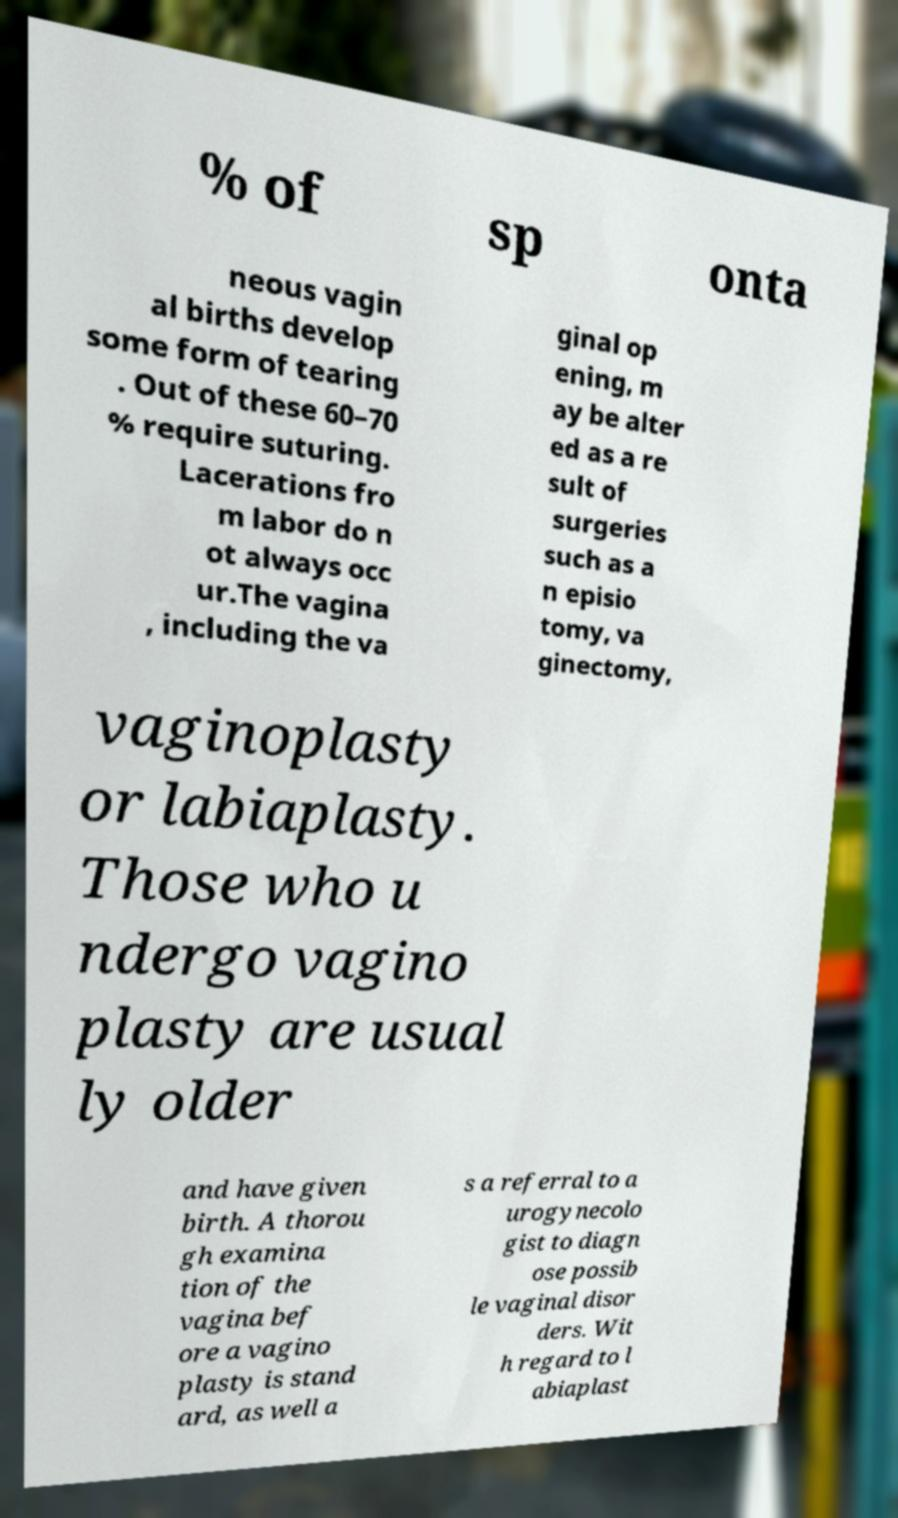Please read and relay the text visible in this image. What does it say? % of sp onta neous vagin al births develop some form of tearing . Out of these 60–70 % require suturing. Lacerations fro m labor do n ot always occ ur.The vagina , including the va ginal op ening, m ay be alter ed as a re sult of surgeries such as a n episio tomy, va ginectomy, vaginoplasty or labiaplasty. Those who u ndergo vagino plasty are usual ly older and have given birth. A thorou gh examina tion of the vagina bef ore a vagino plasty is stand ard, as well a s a referral to a urogynecolo gist to diagn ose possib le vaginal disor ders. Wit h regard to l abiaplast 